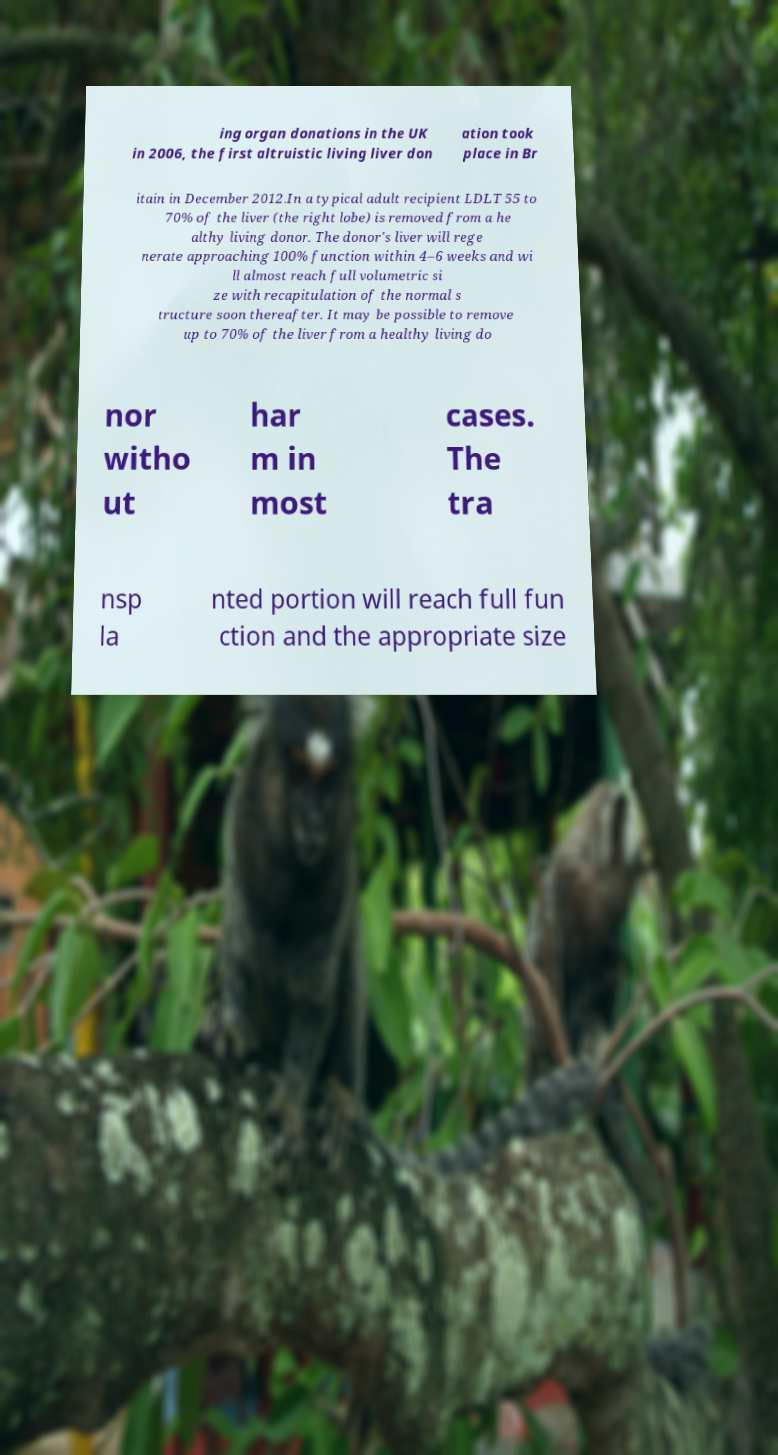Can you read and provide the text displayed in the image?This photo seems to have some interesting text. Can you extract and type it out for me? ing organ donations in the UK in 2006, the first altruistic living liver don ation took place in Br itain in December 2012.In a typical adult recipient LDLT 55 to 70% of the liver (the right lobe) is removed from a he althy living donor. The donor's liver will rege nerate approaching 100% function within 4–6 weeks and wi ll almost reach full volumetric si ze with recapitulation of the normal s tructure soon thereafter. It may be possible to remove up to 70% of the liver from a healthy living do nor witho ut har m in most cases. The tra nsp la nted portion will reach full fun ction and the appropriate size 